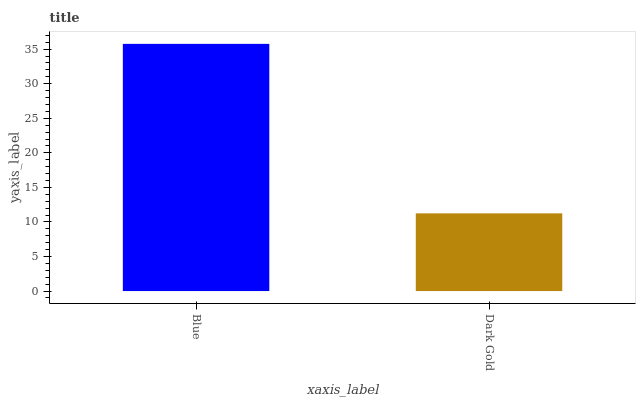Is Dark Gold the minimum?
Answer yes or no. Yes. Is Blue the maximum?
Answer yes or no. Yes. Is Dark Gold the maximum?
Answer yes or no. No. Is Blue greater than Dark Gold?
Answer yes or no. Yes. Is Dark Gold less than Blue?
Answer yes or no. Yes. Is Dark Gold greater than Blue?
Answer yes or no. No. Is Blue less than Dark Gold?
Answer yes or no. No. Is Blue the high median?
Answer yes or no. Yes. Is Dark Gold the low median?
Answer yes or no. Yes. Is Dark Gold the high median?
Answer yes or no. No. Is Blue the low median?
Answer yes or no. No. 